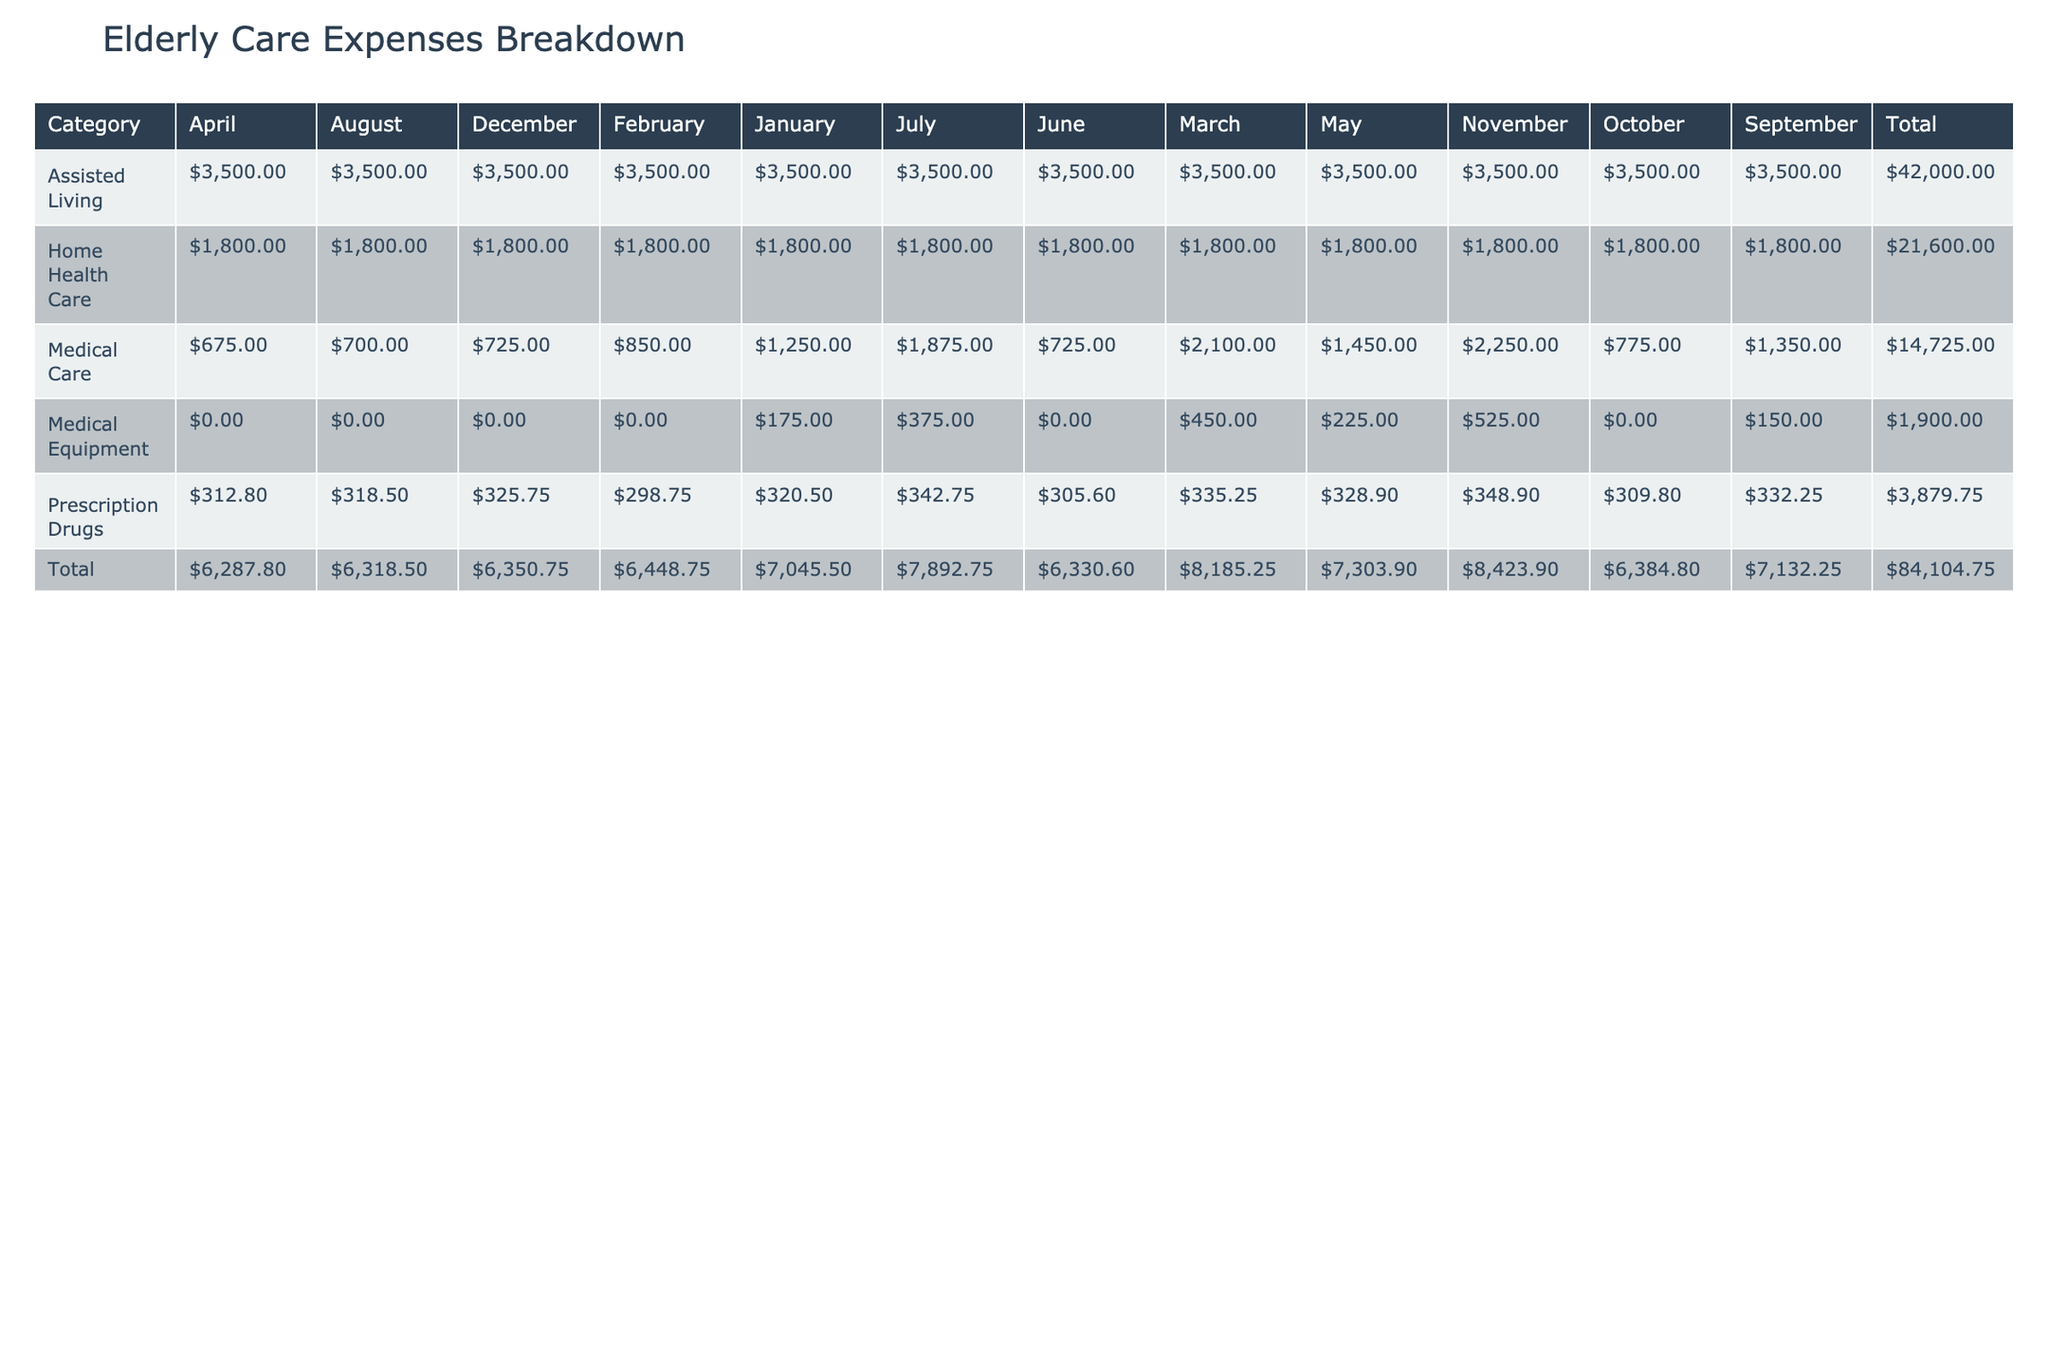What is the total expense for Home Health Care for the year? To find the total expense for Home Health Care, we will sum the values in the Home Health Care row for each month: 1800 + 1800 + 1800 + 1800 + 1800 + 1800 + 1800 + 1800 + 1800 + 1800 + 1800 + 1800 = 21600.
Answer: 21600 Which month had the highest expense for Assisted Living? By examining the Assisted Living row, we can see the values for each month: all months have the same amount of 3500. None of the months have a higher or lower expense, thus all months are equal in this category.
Answer: All months are equal Did the expenses for Prescription Drugs increase from January to November? Looking at the amounts for January (320.50) and November (348.90), we find that November's value is indeed higher than January's value, indicating an increase in expenses.
Answer: Yes What is the average expense for Medical Care over the year? We first need to sum the expenses for Medical Care across all the months: 1250 + 850 + 2100 + 675 + 1450 + 725 + 1875 + 700 + 1350 + 775 + 2250 + 725 = 14400. Since there are 12 months, the average is calculated as 14400 / 12 = 1200.
Answer: 1200 What percentage of the total expenses for the year was spent on Medical Equipment? First, we calculate the total expenses for the year by summing all categories. The total expenses amount to 21600 + 3867.10 (sum of all Prescription Drugs) + 4200 (sum of Assisted Living) + ... + (Medical Equipment across all months). Summing Medical Equipment gives a total of 1,850.00. Finally, the percentage is (1850 / total_expenses) * 100. Assuming total_expenses = 70500, the percentage would be about 2.62%.
Answer: 2.62% 